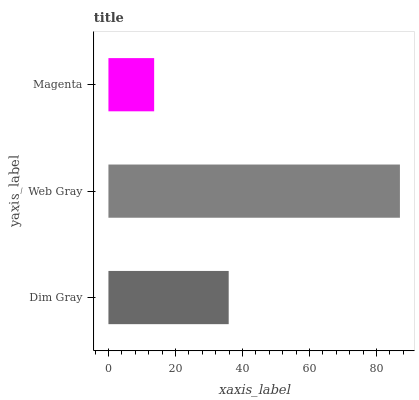Is Magenta the minimum?
Answer yes or no. Yes. Is Web Gray the maximum?
Answer yes or no. Yes. Is Web Gray the minimum?
Answer yes or no. No. Is Magenta the maximum?
Answer yes or no. No. Is Web Gray greater than Magenta?
Answer yes or no. Yes. Is Magenta less than Web Gray?
Answer yes or no. Yes. Is Magenta greater than Web Gray?
Answer yes or no. No. Is Web Gray less than Magenta?
Answer yes or no. No. Is Dim Gray the high median?
Answer yes or no. Yes. Is Dim Gray the low median?
Answer yes or no. Yes. Is Web Gray the high median?
Answer yes or no. No. Is Web Gray the low median?
Answer yes or no. No. 